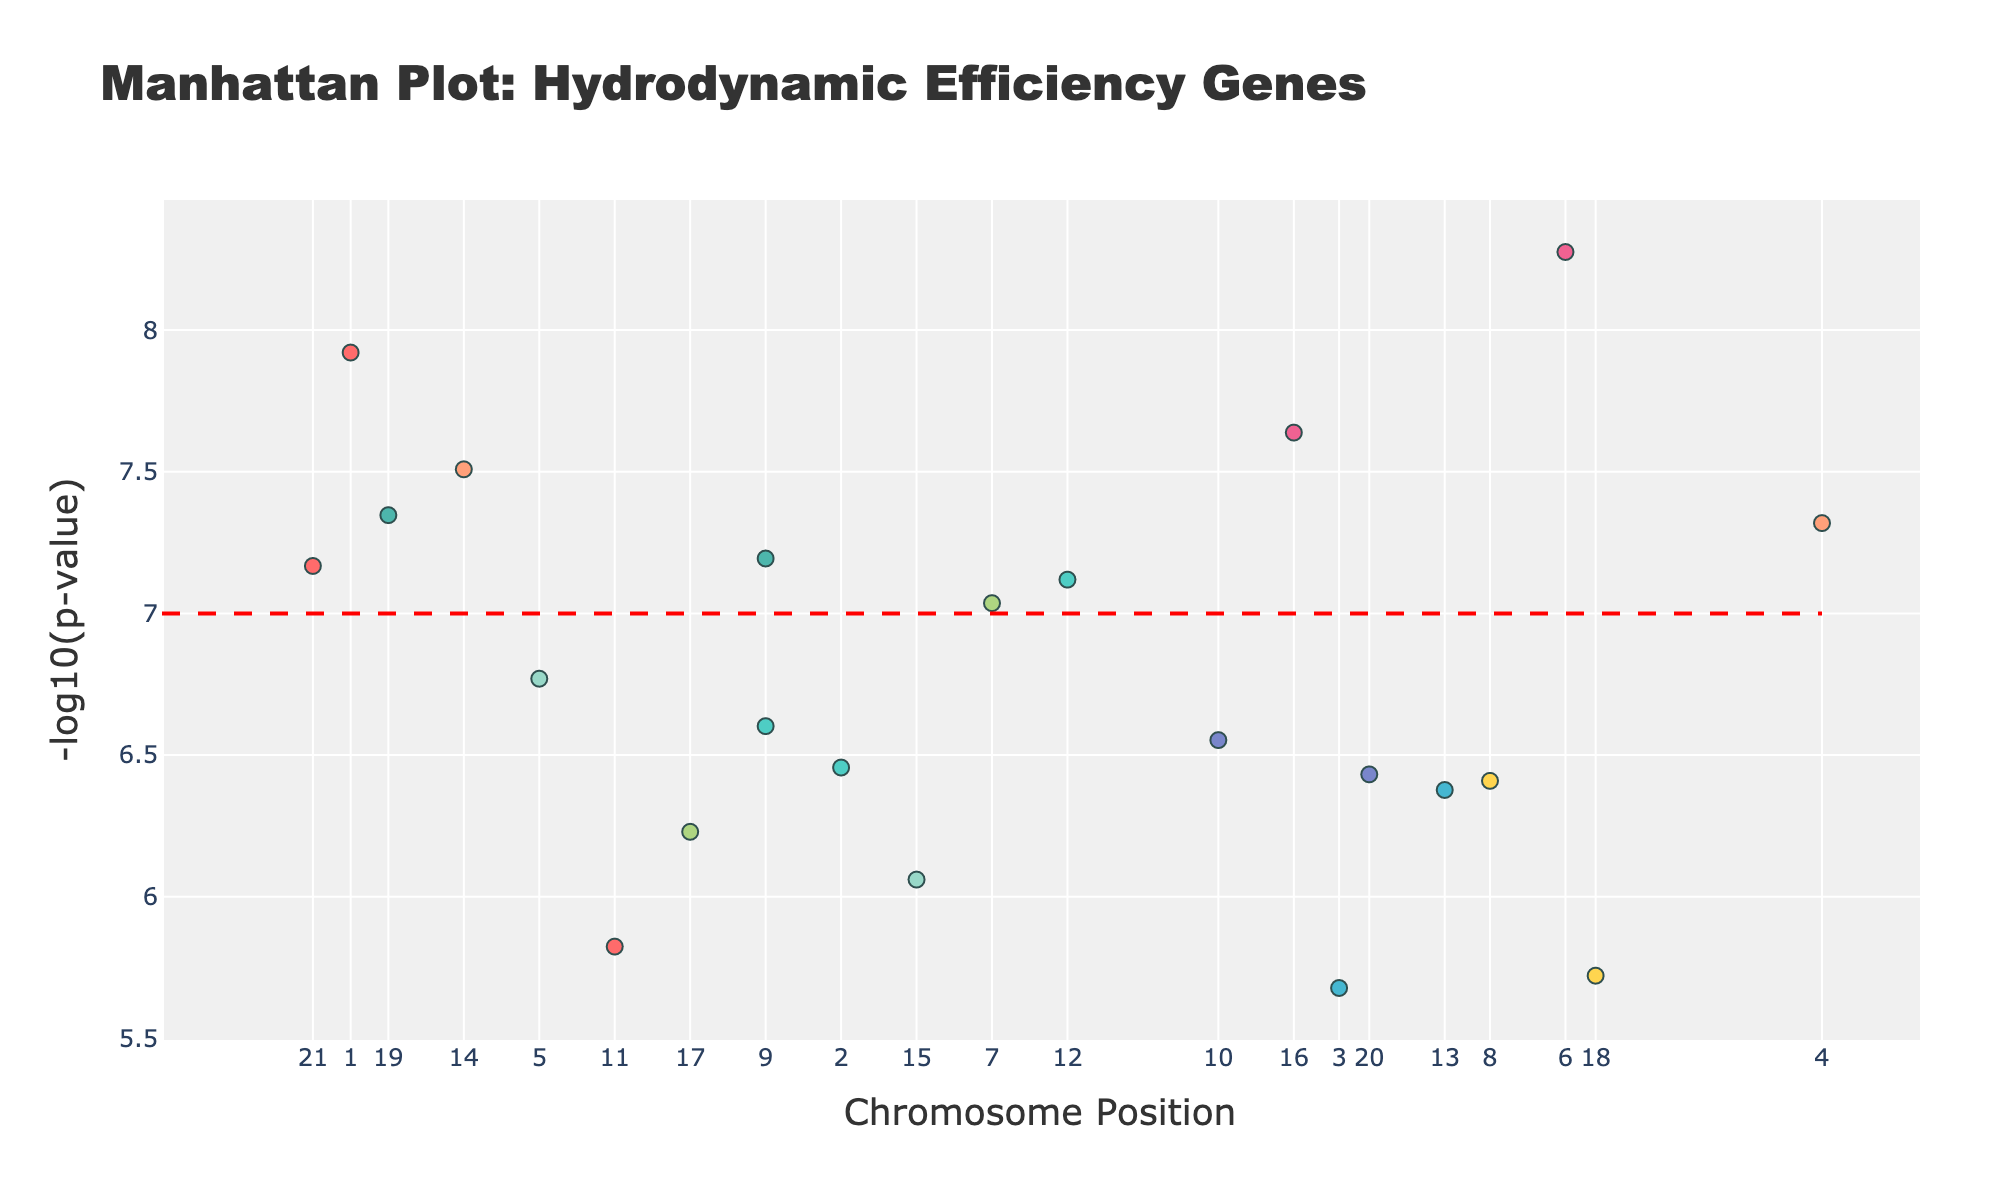How many chromosomes are represented in the plot? Count the number of unique chromosome labels indicated on the x-axis ticks.
Answer: 22 Which gene has the lowest p-value? Identify the gene above the highest -log10(p-value) value on the y-axis.
Answer: BMPR1B Is the gene "ACTA1" below the significance threshold of -log10(5e-8)? Check the height of the data point for "ACTA1" and see if it is below the horizontal line at -log10(5e-8), which is 7.
Answer: Yes What is the chromosome position of the "VEGFA" gene? Locate the "VEGFA" gene and read the position value from the x-axis.
Answer: 55000000 Which chromosome has the highest number of significant genes? Count the number of data points above the significance threshold (line at y=7) for each chromosome and find the chromosome with the highest count.
Answer: Chromosome 6 How many genes are significantly associated with hydrodynamic efficiency traits (p-value < 5e-8)? Count the data points above the significance threshold line (y=7).
Answer: 12 Which gene on chromosome 1 has the lowest p-value? Check the data points on chromosome 1 and identify which one has the highest -log10(p-value).
Answer: PROK2 Which trait is associated with the gene "COL1A1"? Hover over the "COL1A1" data point to read the trait associated with it.
Answer: Skeletal structure Compare the -log10(p-value) of "MYLK" and "PRDM16", which one is higher? Look at the height of the data points for "MYLK" and "PRDM16" and compare their -log10(p-values).
Answer: MYLK On which chromosome is the gene "FOXP2" located? Hover over or look at the data point for "FOXP2" to read its chromosome number.
Answer: Chromosome 3 